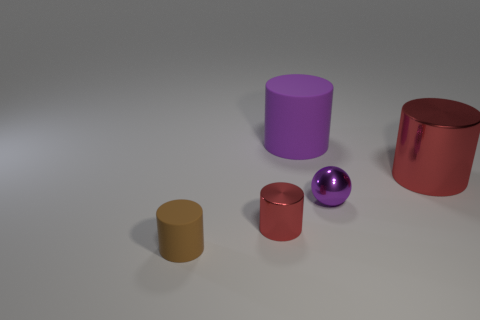Are there any large purple matte objects in front of the small thing in front of the red thing that is to the left of the large red thing?
Your response must be concise. No. Is there anything else that is the same shape as the small purple thing?
Offer a very short reply. No. Are any blue rubber blocks visible?
Offer a very short reply. No. Do the red object to the right of the small red thing and the small cylinder that is to the right of the brown cylinder have the same material?
Provide a succinct answer. Yes. What is the size of the metal cylinder that is in front of the red metal object to the right of the metallic cylinder in front of the purple metal thing?
Keep it short and to the point. Small. What number of tiny brown things have the same material as the large purple cylinder?
Your response must be concise. 1. Is the number of tiny red metal objects less than the number of purple things?
Make the answer very short. Yes. There is another purple rubber object that is the same shape as the small matte object; what size is it?
Provide a succinct answer. Large. Is the material of the cylinder that is behind the large red shiny cylinder the same as the brown object?
Your response must be concise. Yes. Is the brown object the same shape as the big red metallic object?
Provide a short and direct response. Yes. 